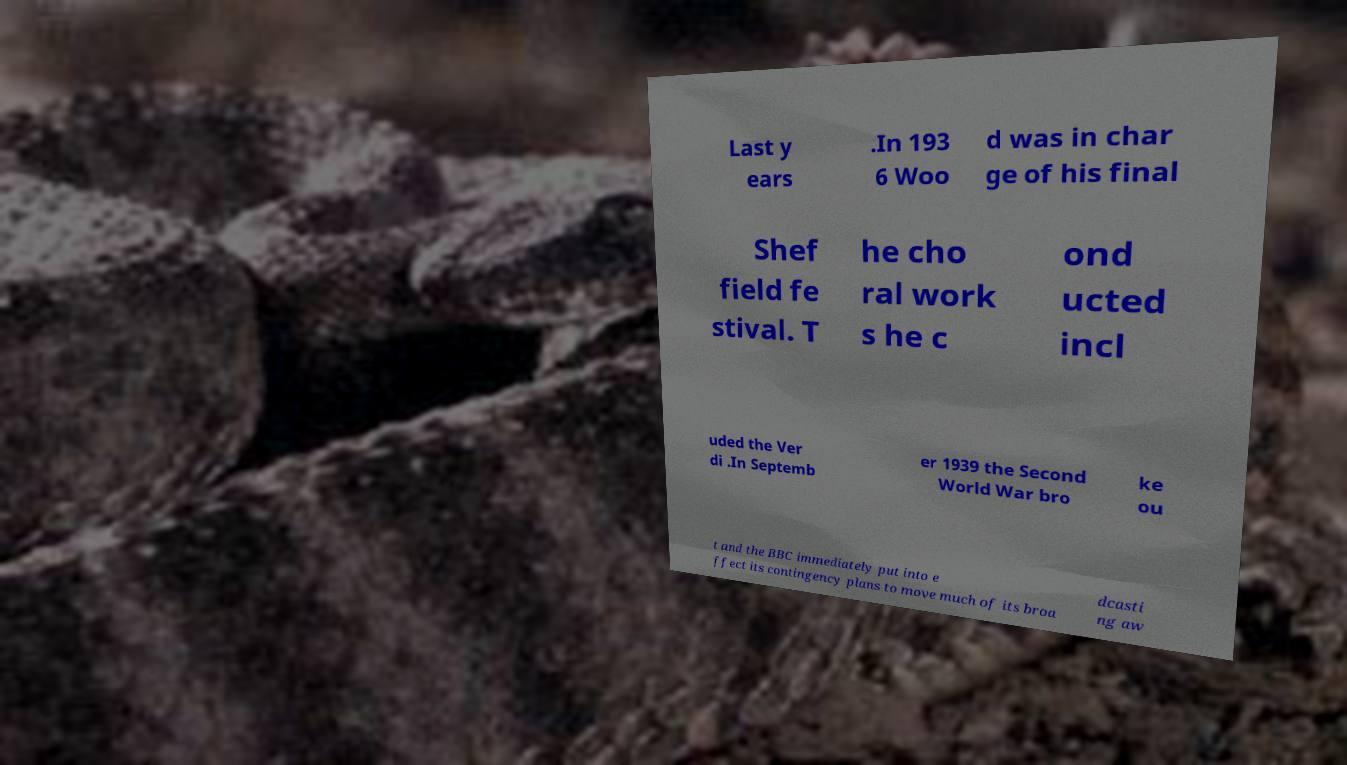What messages or text are displayed in this image? I need them in a readable, typed format. Last y ears .In 193 6 Woo d was in char ge of his final Shef field fe stival. T he cho ral work s he c ond ucted incl uded the Ver di .In Septemb er 1939 the Second World War bro ke ou t and the BBC immediately put into e ffect its contingency plans to move much of its broa dcasti ng aw 